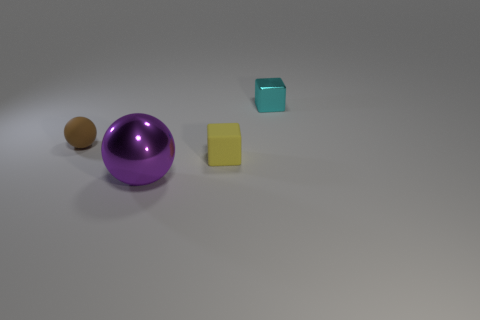Add 3 large purple things. How many objects exist? 7 Add 1 tiny brown rubber balls. How many tiny brown rubber balls are left? 2 Add 1 small rubber spheres. How many small rubber spheres exist? 2 Subtract 0 red cylinders. How many objects are left? 4 Subtract all small brown rubber objects. Subtract all big metallic balls. How many objects are left? 2 